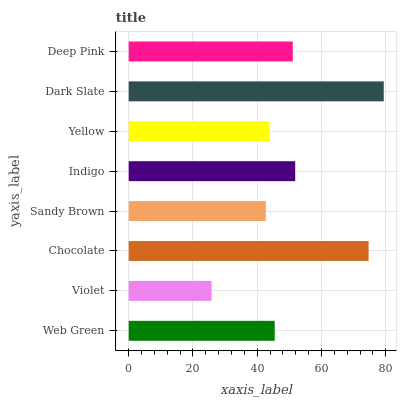Is Violet the minimum?
Answer yes or no. Yes. Is Dark Slate the maximum?
Answer yes or no. Yes. Is Chocolate the minimum?
Answer yes or no. No. Is Chocolate the maximum?
Answer yes or no. No. Is Chocolate greater than Violet?
Answer yes or no. Yes. Is Violet less than Chocolate?
Answer yes or no. Yes. Is Violet greater than Chocolate?
Answer yes or no. No. Is Chocolate less than Violet?
Answer yes or no. No. Is Deep Pink the high median?
Answer yes or no. Yes. Is Web Green the low median?
Answer yes or no. Yes. Is Yellow the high median?
Answer yes or no. No. Is Chocolate the low median?
Answer yes or no. No. 